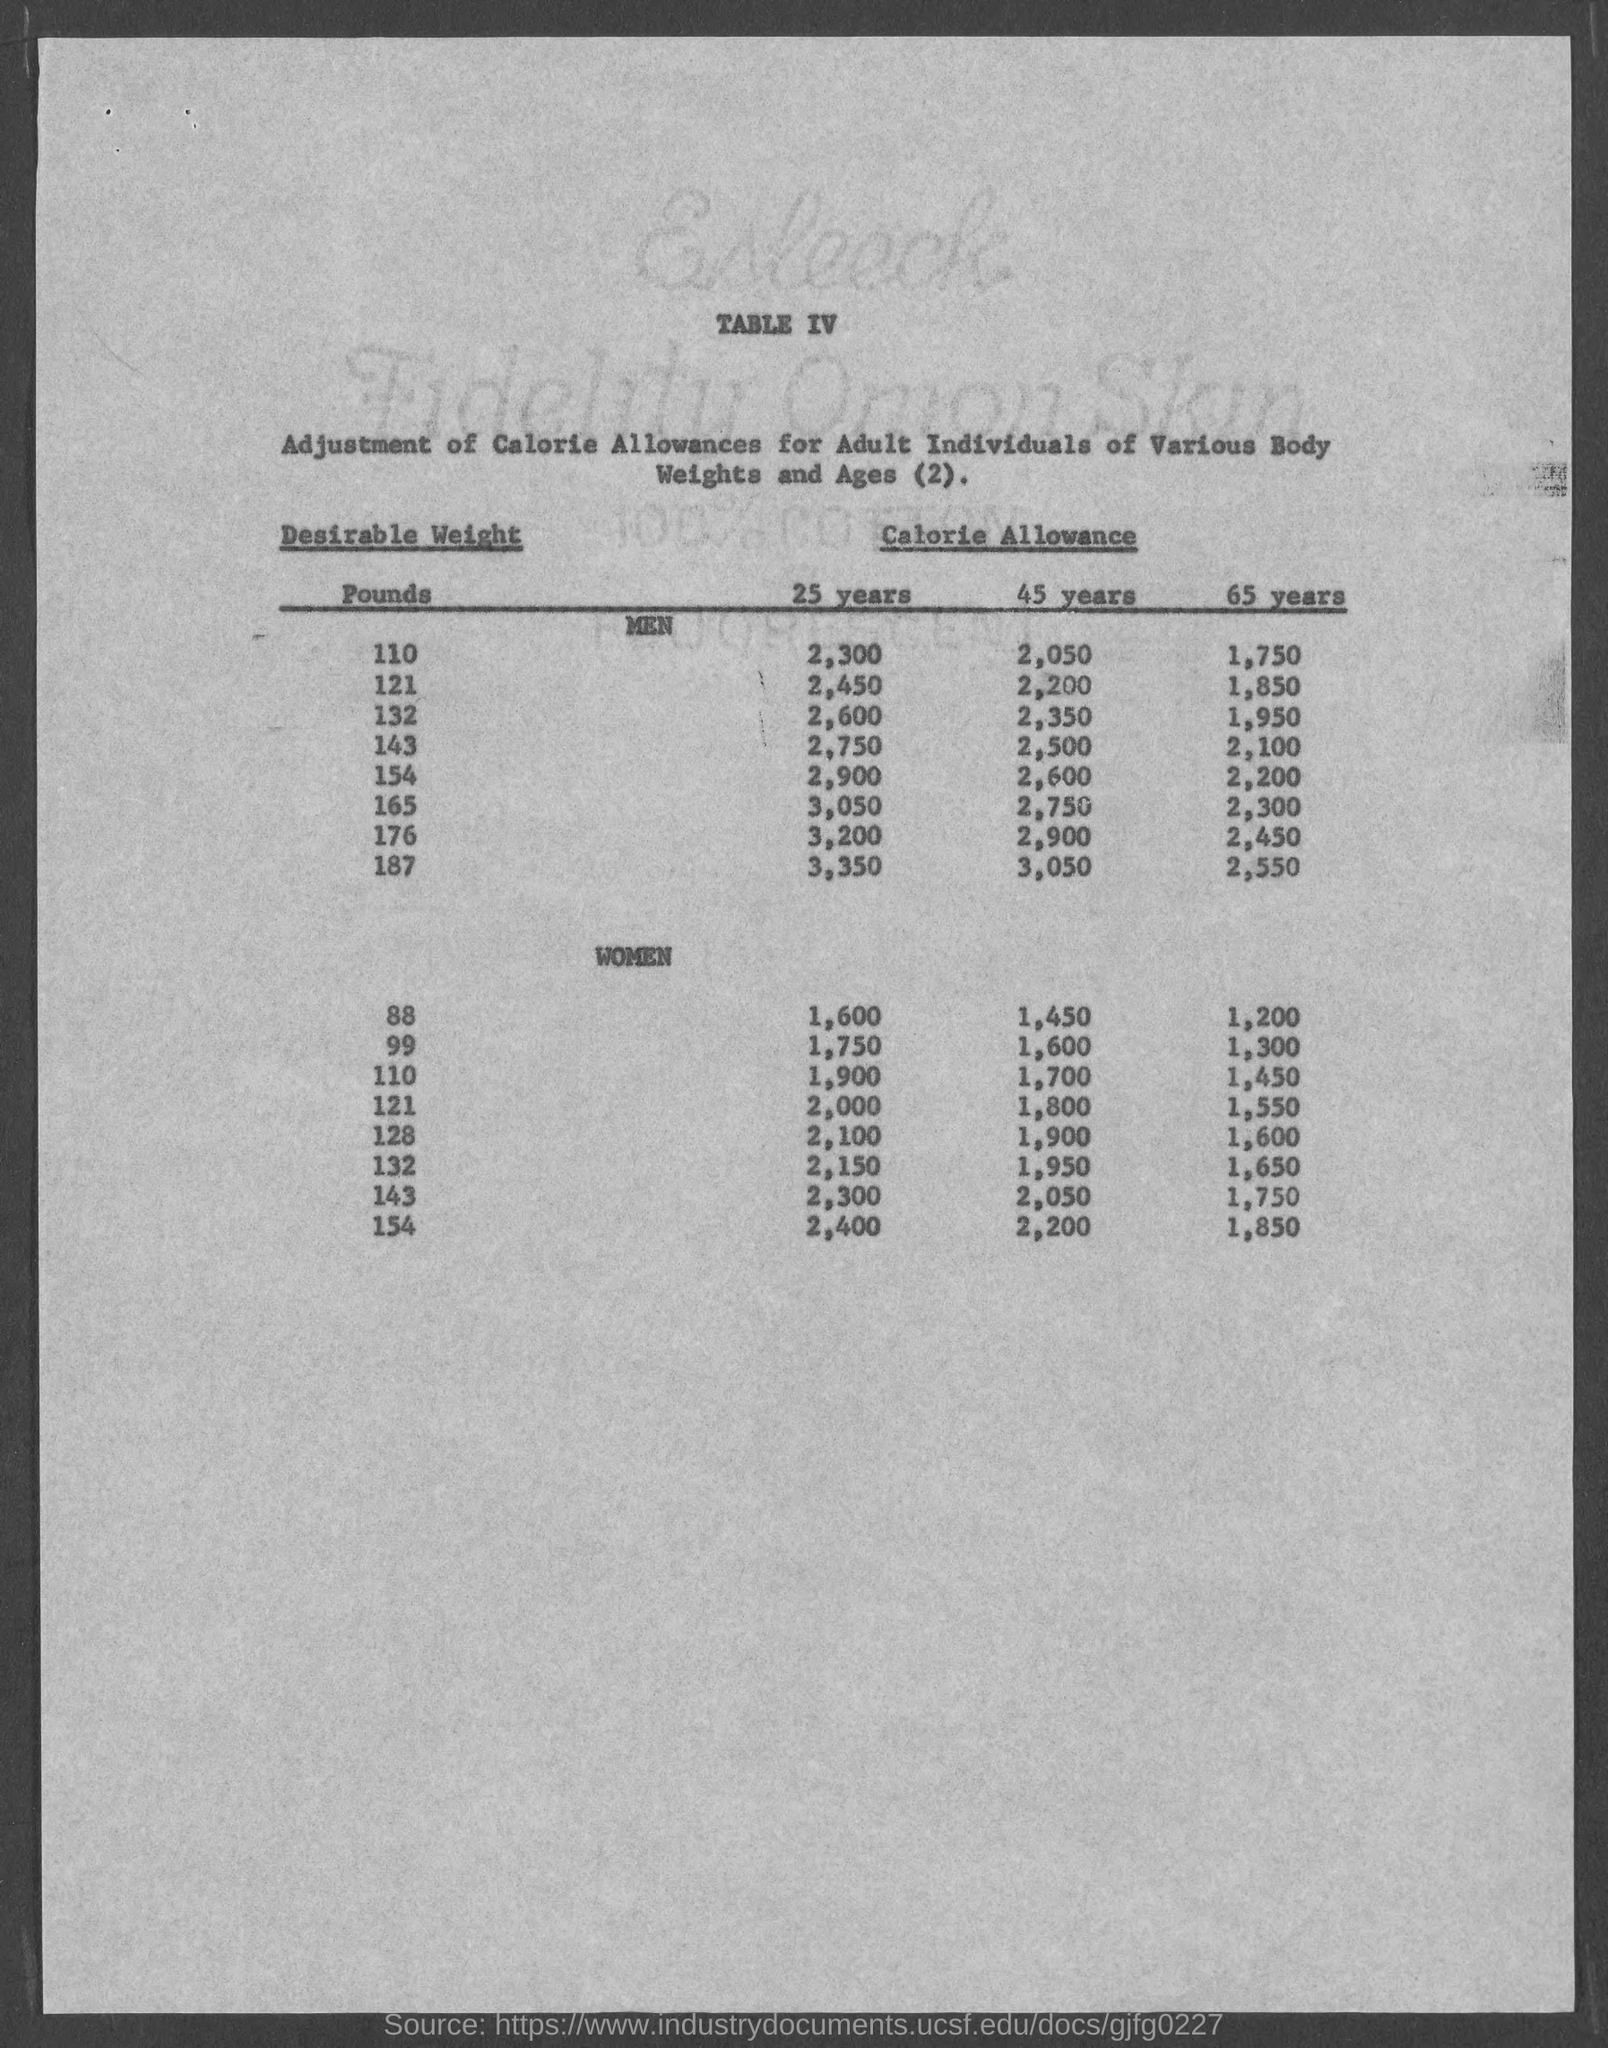What is the table no.?
Ensure brevity in your answer.  IV. What is the calorie allowance, 25 years for desirable weight of 110 pounds in men?
Give a very brief answer. 2,300. What is the calorie allowance, 25 years for desirable weight of 121 pounds in men?
Ensure brevity in your answer.  2,450. What is the calorie allowance, 25 years for desirable weight of 132 pounds in men?
Give a very brief answer. 2,600. What is the calorie allowance, 25 years for desirable weight of 143 pounds in men?
Make the answer very short. 2,750. What is the calorie allowance, 25 years for desirable weight of 154 pounds in men?
Your answer should be very brief. 2,900. What is the calorie allowance, 25 years for desirable weight of 165 pounds in men?
Your answer should be compact. 3,050. What is the calorie allowance, 25 years for desirable weight of 176 pounds in men?
Offer a very short reply. 3,200. What is the calorie allowance, 25 years for desirable weight of 187 pounds in men?
Provide a short and direct response. 3,350. What is the calorie allowance, 45 years for desirable weight of 110 pounds in men?
Make the answer very short. 2,050. 